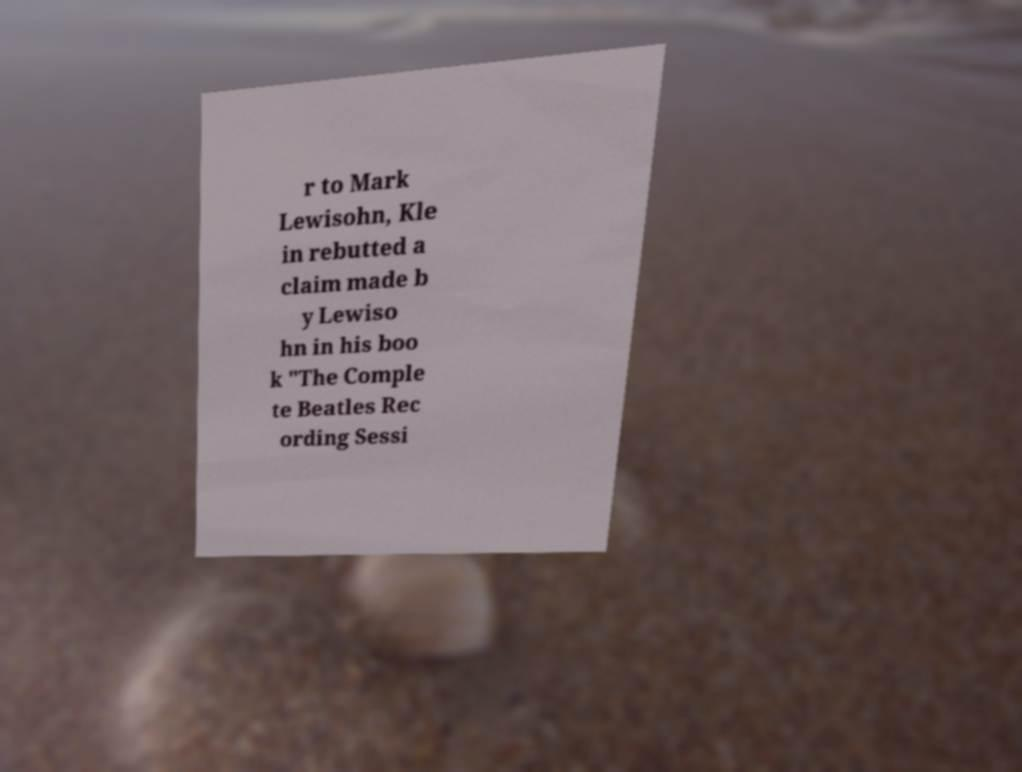There's text embedded in this image that I need extracted. Can you transcribe it verbatim? r to Mark Lewisohn, Kle in rebutted a claim made b y Lewiso hn in his boo k "The Comple te Beatles Rec ording Sessi 